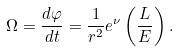<formula> <loc_0><loc_0><loc_500><loc_500>\Omega = \frac { d \varphi } { d t } = \frac { 1 } { r ^ { 2 } } e ^ { \nu } \left ( \frac { L } { E } \right ) .</formula> 